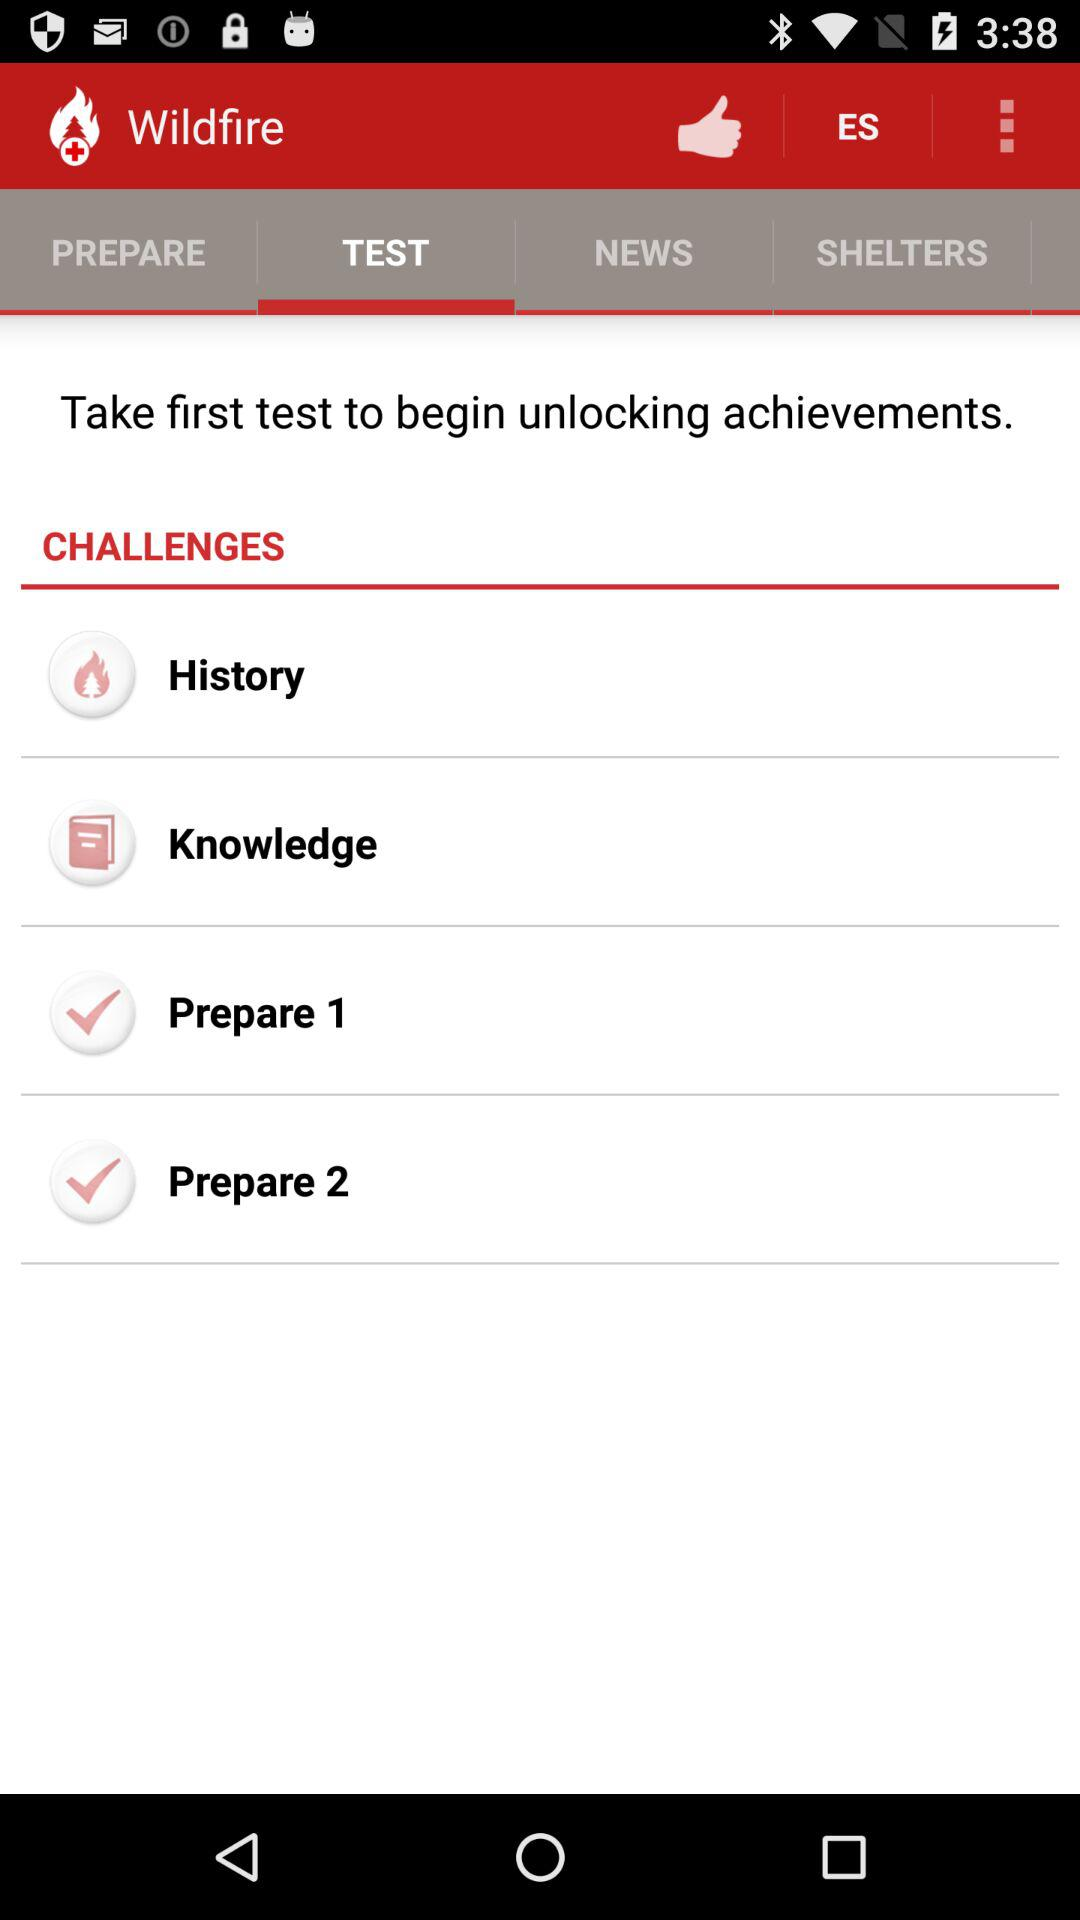What is the app name? The app name is "Wildfire". 